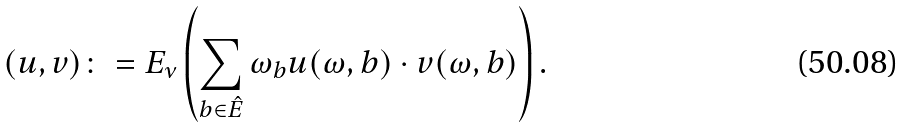<formula> <loc_0><loc_0><loc_500><loc_500>( u , v ) \colon = E _ { \nu } \left ( \sum _ { b \in \hat { E } } \omega _ { b } u ( \omega , b ) \cdot v ( \omega , b ) \right ) .</formula> 